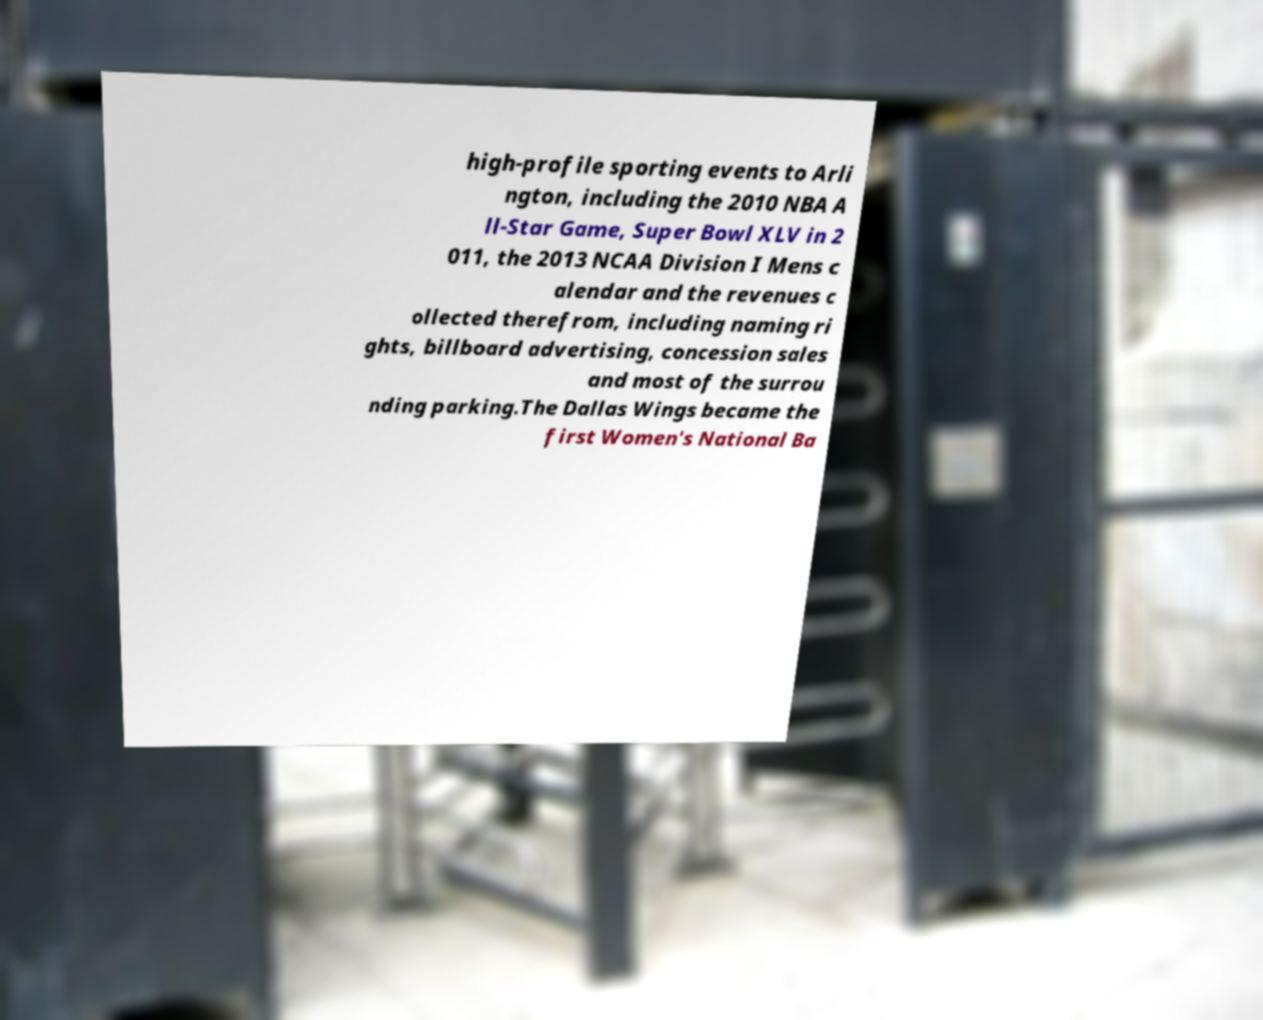Please identify and transcribe the text found in this image. high-profile sporting events to Arli ngton, including the 2010 NBA A ll-Star Game, Super Bowl XLV in 2 011, the 2013 NCAA Division I Mens c alendar and the revenues c ollected therefrom, including naming ri ghts, billboard advertising, concession sales and most of the surrou nding parking.The Dallas Wings became the first Women's National Ba 